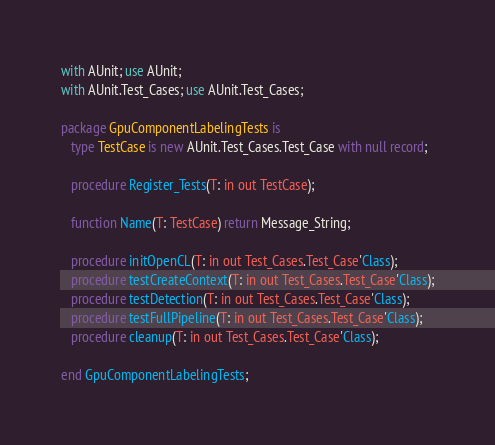<code> <loc_0><loc_0><loc_500><loc_500><_Ada_>with AUnit; use AUnit;
with AUnit.Test_Cases; use AUnit.Test_Cases;

package GpuComponentLabelingTests is
   type TestCase is new AUnit.Test_Cases.Test_Case with null record;

   procedure Register_Tests(T: in out TestCase);

   function Name(T: TestCase) return Message_String;

   procedure initOpenCL(T: in out Test_Cases.Test_Case'Class);
   procedure testCreateContext(T: in out Test_Cases.Test_Case'Class);
   procedure testDetection(T: in out Test_Cases.Test_Case'Class);
   procedure testFullPipeline(T: in out Test_Cases.Test_Case'Class);
   procedure cleanup(T: in out Test_Cases.Test_Case'Class);

end GpuComponentLabelingTests;
</code> 